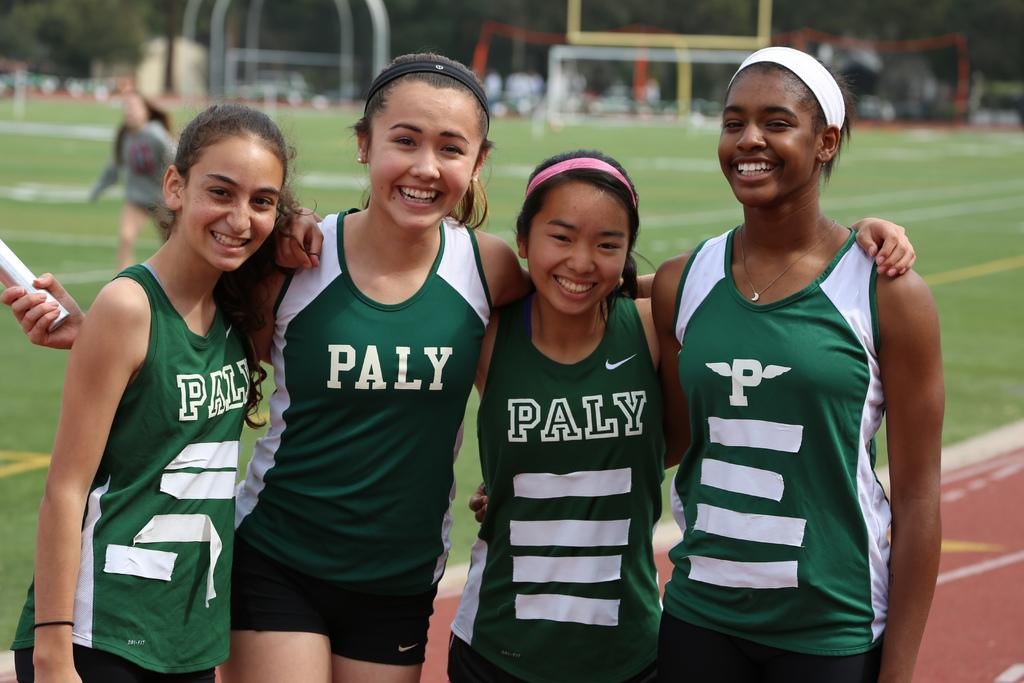<image>
Describe the image concisely. Four track athletes for PALY gather together on the track. 